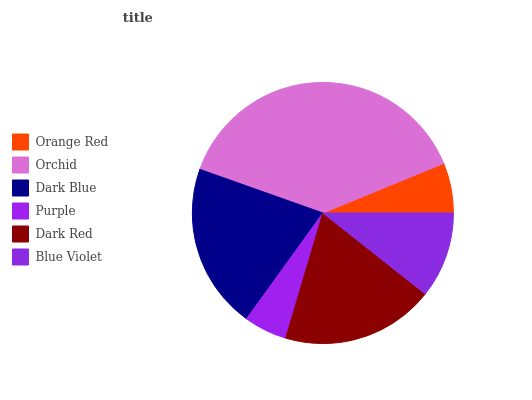Is Purple the minimum?
Answer yes or no. Yes. Is Orchid the maximum?
Answer yes or no. Yes. Is Dark Blue the minimum?
Answer yes or no. No. Is Dark Blue the maximum?
Answer yes or no. No. Is Orchid greater than Dark Blue?
Answer yes or no. Yes. Is Dark Blue less than Orchid?
Answer yes or no. Yes. Is Dark Blue greater than Orchid?
Answer yes or no. No. Is Orchid less than Dark Blue?
Answer yes or no. No. Is Dark Red the high median?
Answer yes or no. Yes. Is Blue Violet the low median?
Answer yes or no. Yes. Is Orange Red the high median?
Answer yes or no. No. Is Purple the low median?
Answer yes or no. No. 